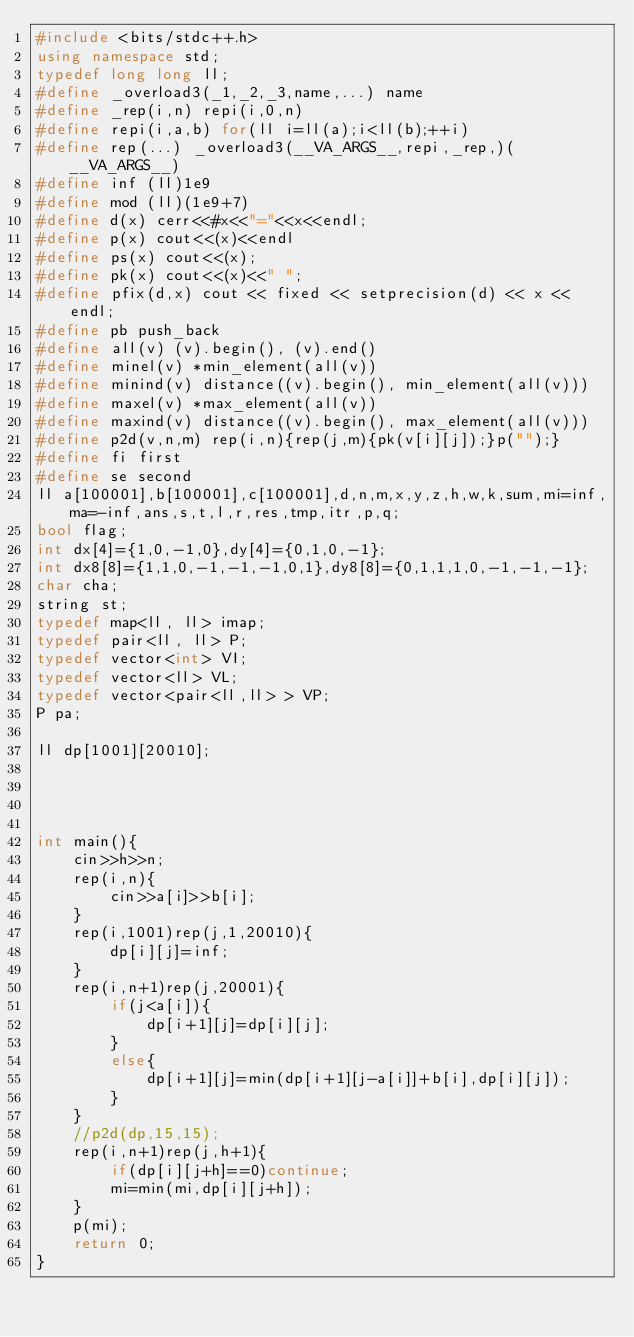Convert code to text. <code><loc_0><loc_0><loc_500><loc_500><_C++_>#include <bits/stdc++.h>
using namespace std;
typedef long long ll;
#define _overload3(_1,_2,_3,name,...) name
#define _rep(i,n) repi(i,0,n)
#define repi(i,a,b) for(ll i=ll(a);i<ll(b);++i)
#define rep(...) _overload3(__VA_ARGS__,repi,_rep,)(__VA_ARGS__)
#define inf (ll)1e9
#define mod (ll)(1e9+7)
#define d(x) cerr<<#x<<"="<<x<<endl;
#define p(x) cout<<(x)<<endl
#define ps(x) cout<<(x);
#define pk(x) cout<<(x)<<" ";
#define pfix(d,x) cout << fixed << setprecision(d) << x << endl;
#define pb push_back
#define all(v) (v).begin(), (v).end()
#define minel(v) *min_element(all(v))
#define minind(v) distance((v).begin(), min_element(all(v)))
#define maxel(v) *max_element(all(v))
#define maxind(v) distance((v).begin(), max_element(all(v)))
#define p2d(v,n,m) rep(i,n){rep(j,m){pk(v[i][j]);}p("");}
#define fi first
#define se second
ll a[100001],b[100001],c[100001],d,n,m,x,y,z,h,w,k,sum,mi=inf,ma=-inf,ans,s,t,l,r,res,tmp,itr,p,q;
bool flag;
int dx[4]={1,0,-1,0},dy[4]={0,1,0,-1};
int dx8[8]={1,1,0,-1,-1,-1,0,1},dy8[8]={0,1,1,1,0,-1,-1,-1};
char cha;
string st;
typedef map<ll, ll> imap;
typedef pair<ll, ll> P;
typedef vector<int> VI;
typedef vector<ll> VL;
typedef vector<pair<ll,ll> > VP;
P pa;

ll dp[1001][20010];




int main(){
    cin>>h>>n;
    rep(i,n){
        cin>>a[i]>>b[i];
    }
    rep(i,1001)rep(j,1,20010){
        dp[i][j]=inf;
    }
    rep(i,n+1)rep(j,20001){
        if(j<a[i]){
            dp[i+1][j]=dp[i][j];
        }
        else{
            dp[i+1][j]=min(dp[i+1][j-a[i]]+b[i],dp[i][j]);
        }
    }
    //p2d(dp,15,15);
    rep(i,n+1)rep(j,h+1){
        if(dp[i][j+h]==0)continue;
        mi=min(mi,dp[i][j+h]);
    }
    p(mi);
    return 0;
}
</code> 